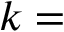<formula> <loc_0><loc_0><loc_500><loc_500>k =</formula> 